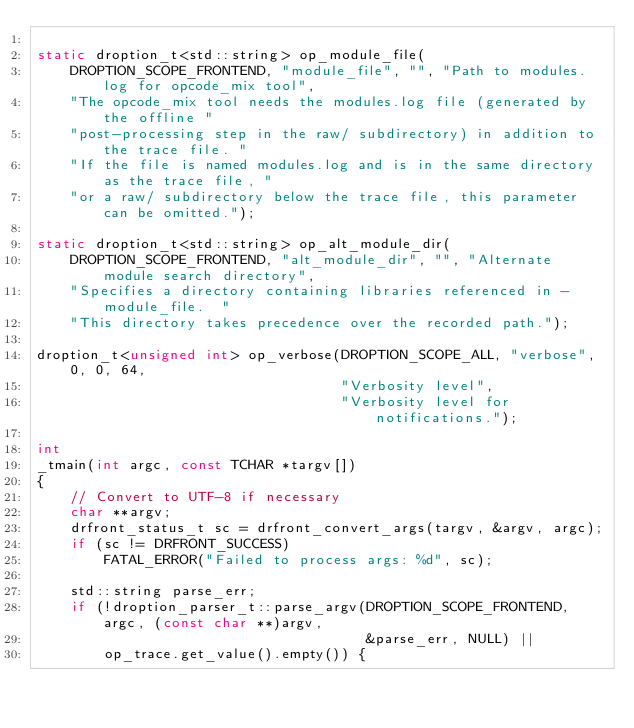<code> <loc_0><loc_0><loc_500><loc_500><_C++_>
static droption_t<std::string> op_module_file(
    DROPTION_SCOPE_FRONTEND, "module_file", "", "Path to modules.log for opcode_mix tool",
    "The opcode_mix tool needs the modules.log file (generated by the offline "
    "post-processing step in the raw/ subdirectory) in addition to the trace file. "
    "If the file is named modules.log and is in the same directory as the trace file, "
    "or a raw/ subdirectory below the trace file, this parameter can be omitted.");

static droption_t<std::string> op_alt_module_dir(
    DROPTION_SCOPE_FRONTEND, "alt_module_dir", "", "Alternate module search directory",
    "Specifies a directory containing libraries referenced in -module_file.  "
    "This directory takes precedence over the recorded path.");

droption_t<unsigned int> op_verbose(DROPTION_SCOPE_ALL, "verbose", 0, 0, 64,
                                    "Verbosity level",
                                    "Verbosity level for notifications.");

int
_tmain(int argc, const TCHAR *targv[])
{
    // Convert to UTF-8 if necessary
    char **argv;
    drfront_status_t sc = drfront_convert_args(targv, &argv, argc);
    if (sc != DRFRONT_SUCCESS)
        FATAL_ERROR("Failed to process args: %d", sc);

    std::string parse_err;
    if (!droption_parser_t::parse_argv(DROPTION_SCOPE_FRONTEND, argc, (const char **)argv,
                                       &parse_err, NULL) ||
        op_trace.get_value().empty()) {</code> 